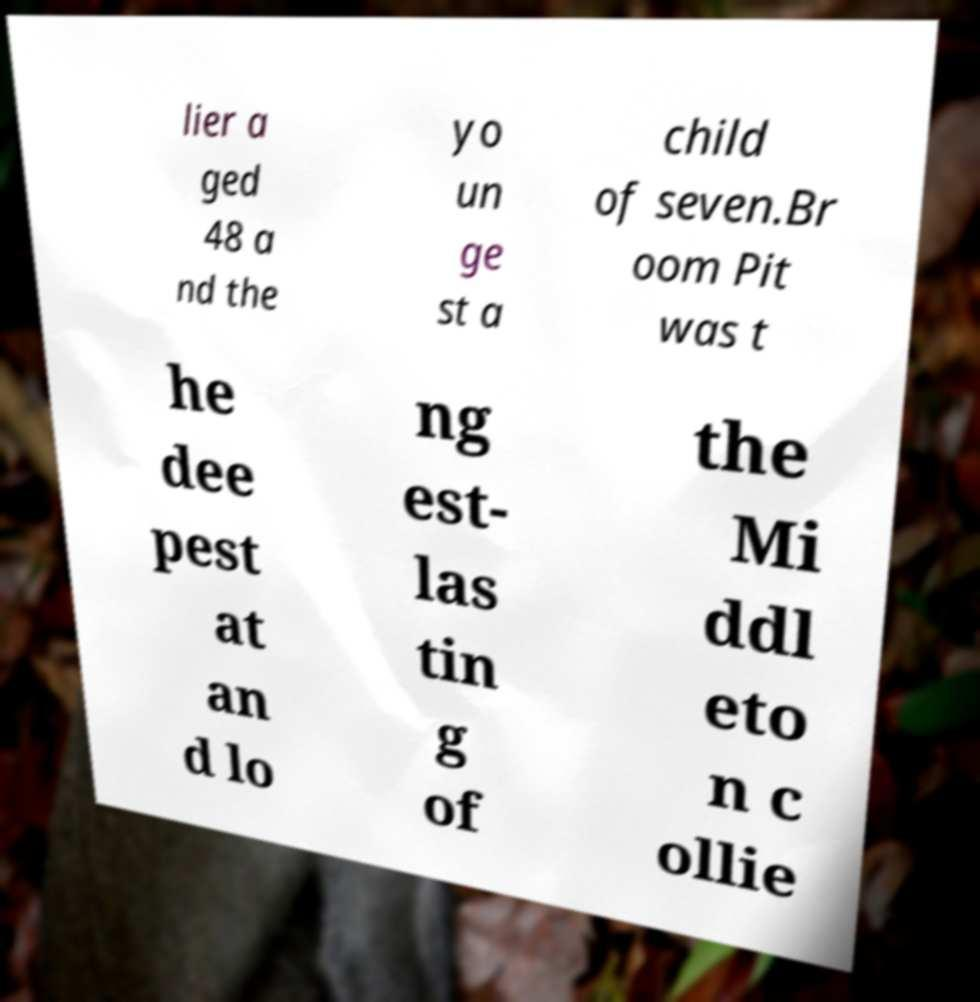Please identify and transcribe the text found in this image. lier a ged 48 a nd the yo un ge st a child of seven.Br oom Pit was t he dee pest at an d lo ng est- las tin g of the Mi ddl eto n c ollie 